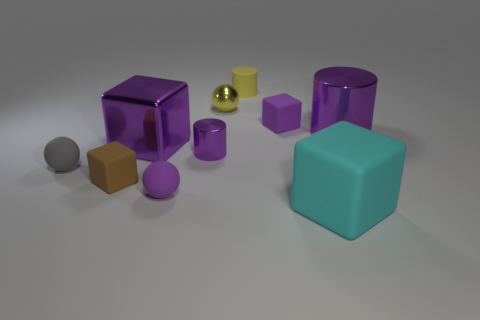Subtract all cyan cubes. How many cubes are left? 3 Subtract 1 blocks. How many blocks are left? 3 Subtract all gray blocks. Subtract all blue balls. How many blocks are left? 4 Subtract all cubes. How many objects are left? 6 Subtract 0 brown spheres. How many objects are left? 10 Subtract all tiny cyan shiny balls. Subtract all metallic balls. How many objects are left? 9 Add 3 big metal cubes. How many big metal cubes are left? 4 Add 8 brown cylinders. How many brown cylinders exist? 8 